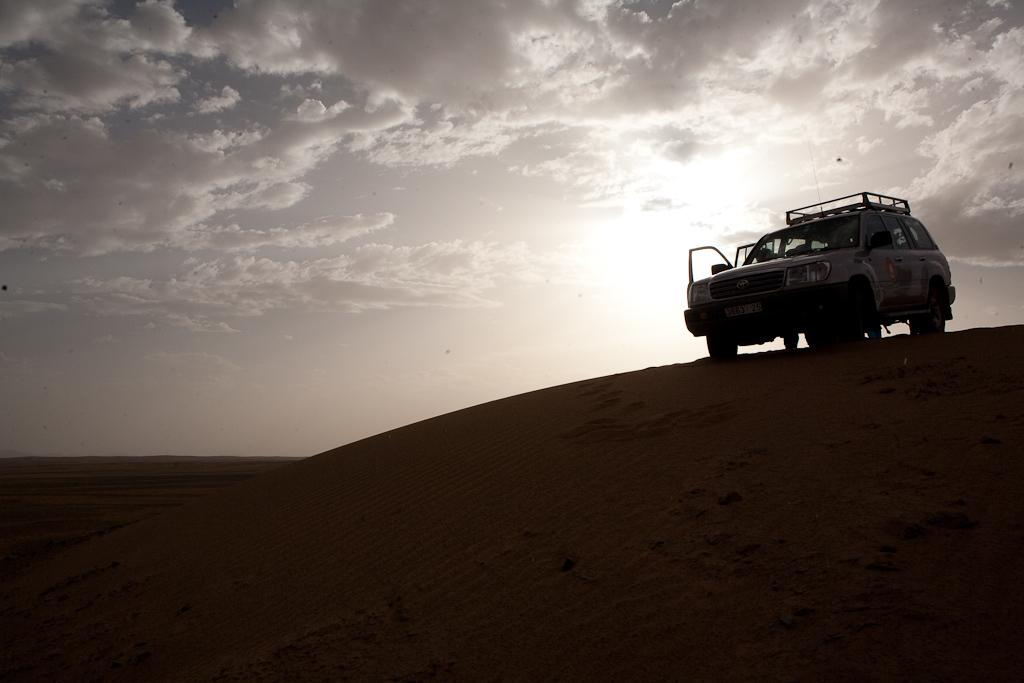What type of vehicle is on the land in the image? The specific type of vehicle is not mentioned, but there is a vehicle on the land in the image. What can be seen at the top of the image? The sky is visible at the top of the image. What is the condition of the sky in the image? There are clouds in the sky. How does the father use his arm to grip the vehicle in the image? There is no father or arm present in the image; it only features a vehicle on the land and clouds in the sky. 